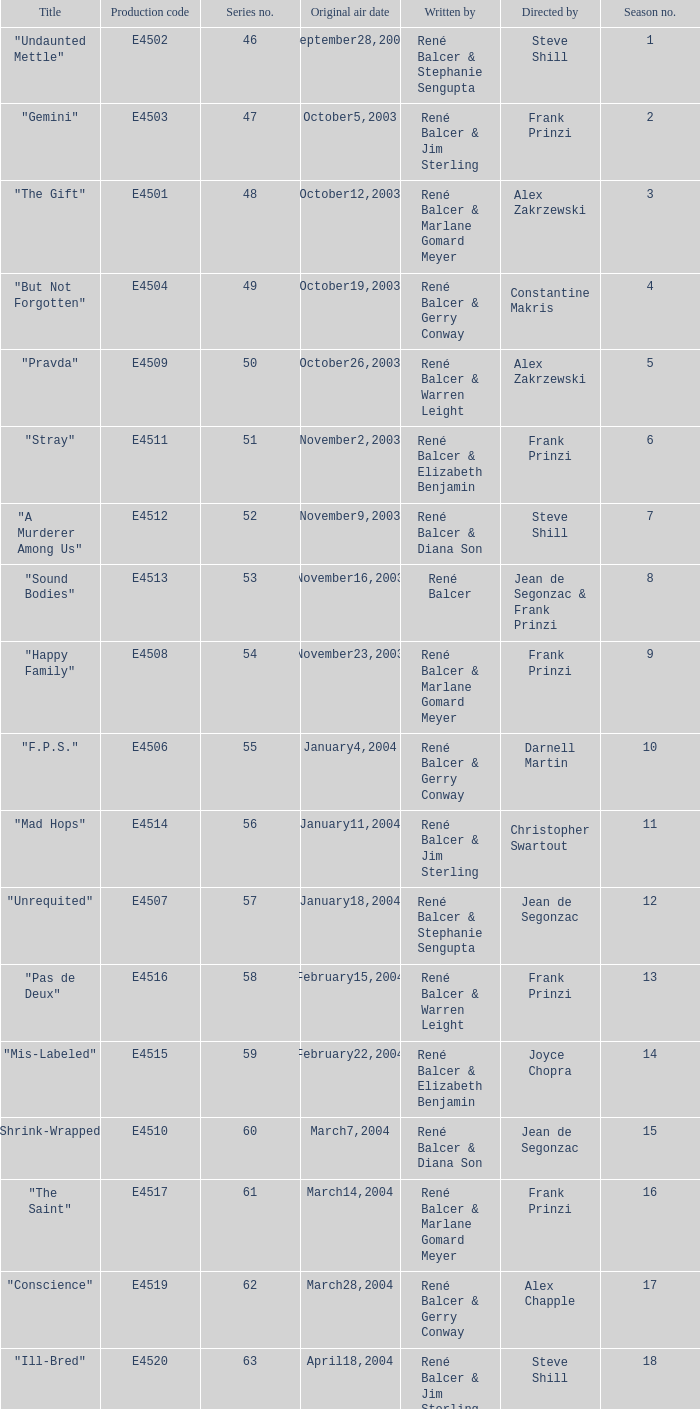Who wrote the episode with e4515 as the production code? René Balcer & Elizabeth Benjamin. Can you give me this table as a dict? {'header': ['Title', 'Production code', 'Series no.', 'Original air date', 'Written by', 'Directed by', 'Season no.'], 'rows': [['"Undaunted Mettle"', 'E4502', '46', 'September28,2003', 'René Balcer & Stephanie Sengupta', 'Steve Shill', '1'], ['"Gemini"', 'E4503', '47', 'October5,2003', 'René Balcer & Jim Sterling', 'Frank Prinzi', '2'], ['"The Gift"', 'E4501', '48', 'October12,2003', 'René Balcer & Marlane Gomard Meyer', 'Alex Zakrzewski', '3'], ['"But Not Forgotten"', 'E4504', '49', 'October19,2003', 'René Balcer & Gerry Conway', 'Constantine Makris', '4'], ['"Pravda"', 'E4509', '50', 'October26,2003', 'René Balcer & Warren Leight', 'Alex Zakrzewski', '5'], ['"Stray"', 'E4511', '51', 'November2,2003', 'René Balcer & Elizabeth Benjamin', 'Frank Prinzi', '6'], ['"A Murderer Among Us"', 'E4512', '52', 'November9,2003', 'René Balcer & Diana Son', 'Steve Shill', '7'], ['"Sound Bodies"', 'E4513', '53', 'November16,2003', 'René Balcer', 'Jean de Segonzac & Frank Prinzi', '8'], ['"Happy Family"', 'E4508', '54', 'November23,2003', 'René Balcer & Marlane Gomard Meyer', 'Frank Prinzi', '9'], ['"F.P.S."', 'E4506', '55', 'January4,2004', 'René Balcer & Gerry Conway', 'Darnell Martin', '10'], ['"Mad Hops"', 'E4514', '56', 'January11,2004', 'René Balcer & Jim Sterling', 'Christopher Swartout', '11'], ['"Unrequited"', 'E4507', '57', 'January18,2004', 'René Balcer & Stephanie Sengupta', 'Jean de Segonzac', '12'], ['"Pas de Deux"', 'E4516', '58', 'February15,2004', 'René Balcer & Warren Leight', 'Frank Prinzi', '13'], ['"Mis-Labeled"', 'E4515', '59', 'February22,2004', 'René Balcer & Elizabeth Benjamin', 'Joyce Chopra', '14'], ['"Shrink-Wrapped"', 'E4510', '60', 'March7,2004', 'René Balcer & Diana Son', 'Jean de Segonzac', '15'], ['"The Saint"', 'E4517', '61', 'March14,2004', 'René Balcer & Marlane Gomard Meyer', 'Frank Prinzi', '16'], ['"Conscience"', 'E4519', '62', 'March28,2004', 'René Balcer & Gerry Conway', 'Alex Chapple', '17'], ['"Ill-Bred"', 'E4520', '63', 'April18,2004', 'René Balcer & Jim Sterling', 'Steve Shill', '18'], ['"Fico di Capo"', 'E4518', '64', 'May9,2004', 'René Balcer & Stephanie Sengupta', 'Alex Zakrzewski', '19'], ['"D.A.W."', 'E4522', '65', 'May16,2004', 'René Balcer & Warren Leight', 'Frank Prinzi', '20']]} 